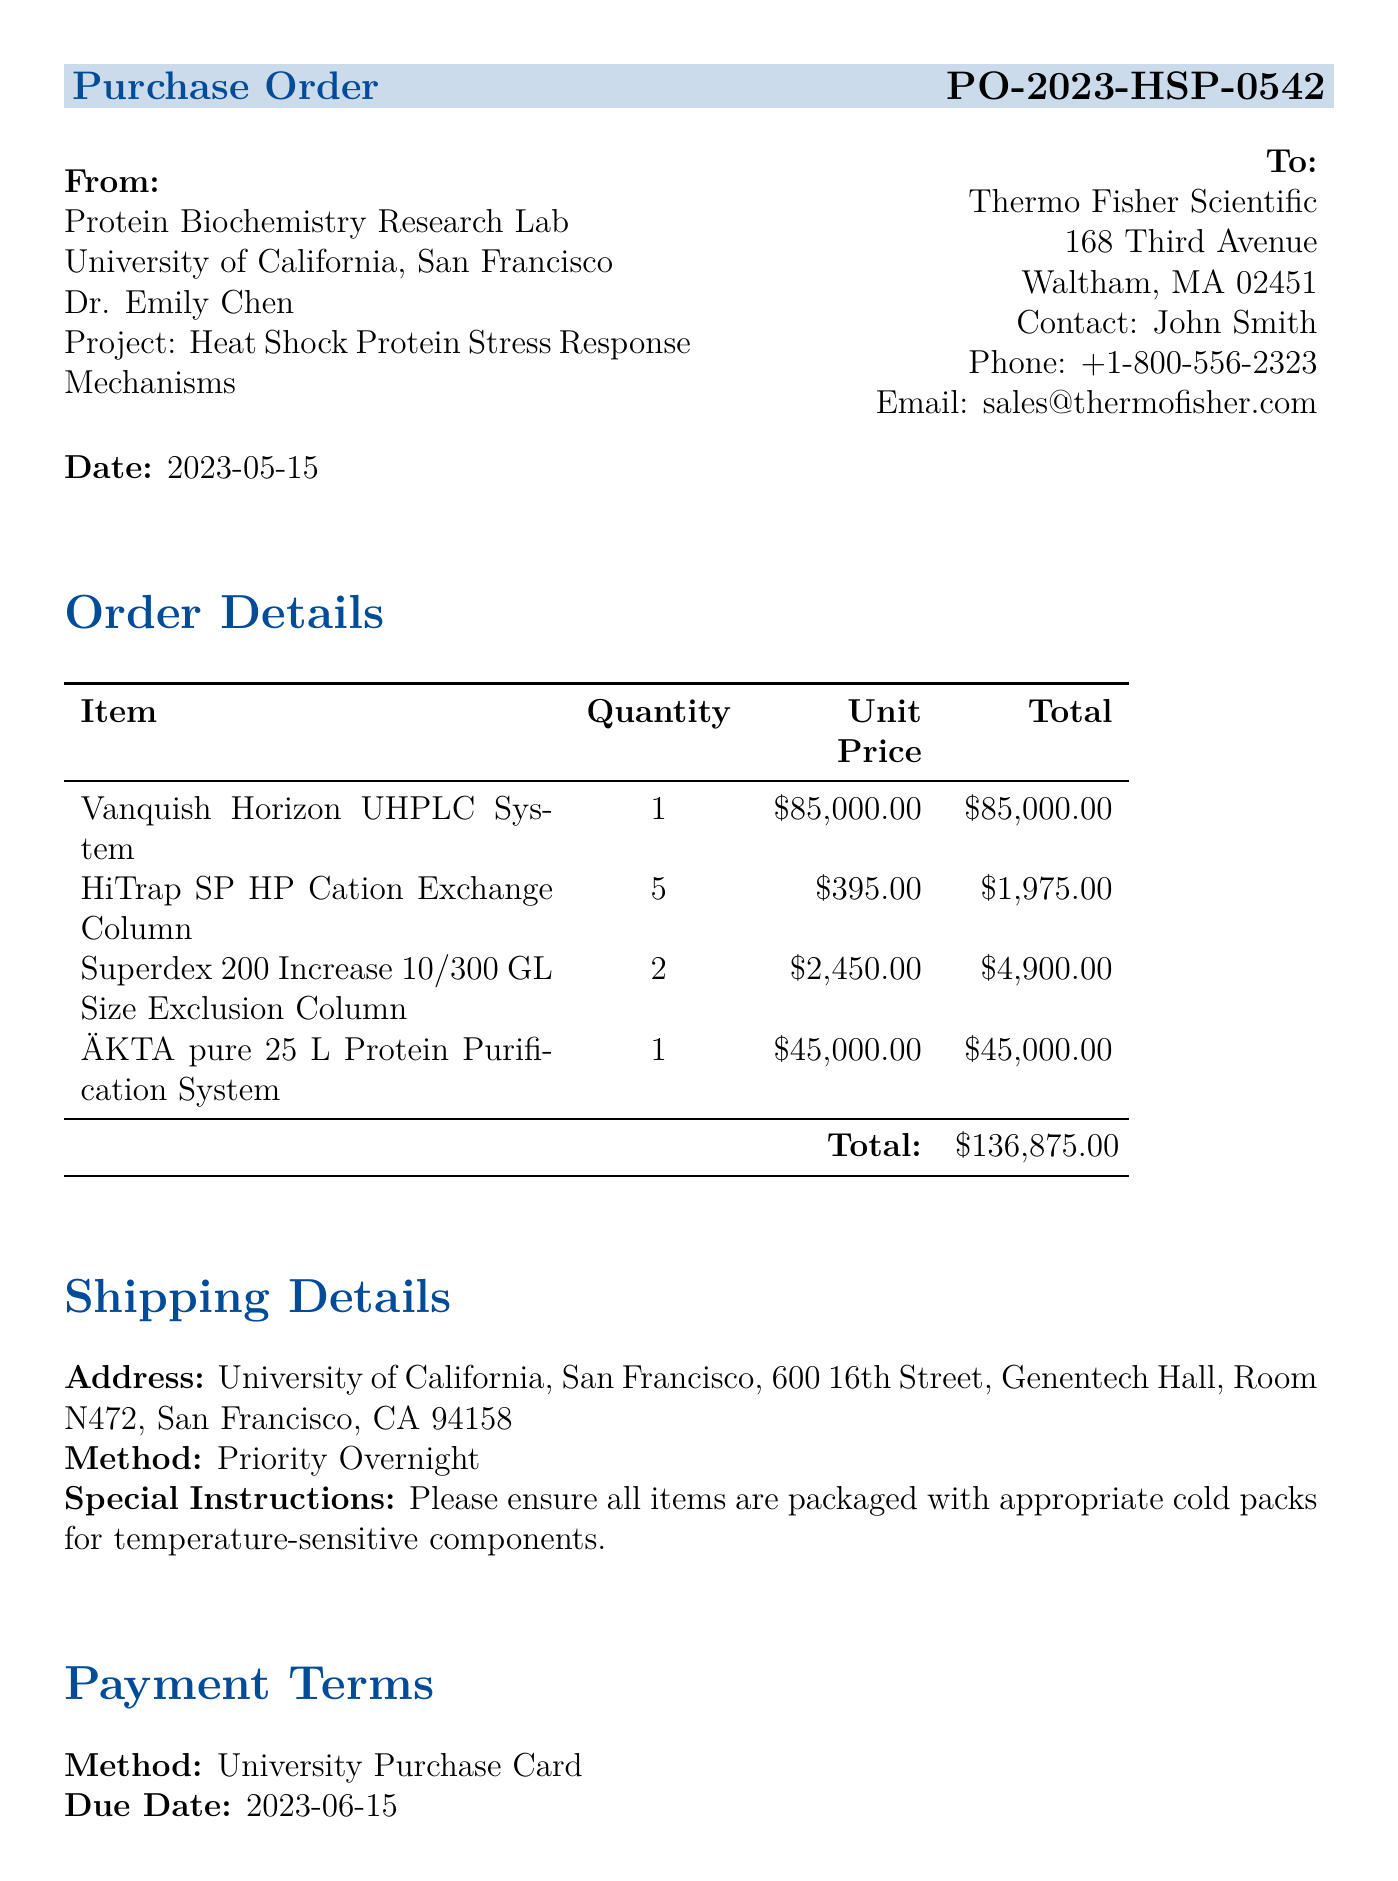What is the order number? The order number is provided in the document under purchase order details, which is PO-2023-HSP-0542.
Answer: PO-2023-HSP-0542 Who is the principal investigator? The principal investigator is mentioned in the approvals section of the document as Dr. Emily Chen.
Answer: Dr. Emily Chen What is the total price of the Vanquish Horizon UHPLC System? The total price of the Vanquish Horizon UHPLC System is listed in the order details section, which is $85,000.00.
Answer: $85,000.00 How many HiTrap SP HP Cation Exchange Columns were ordered? The quantity of HiTrap SP HP Cation Exchange Columns is specified in the order details as 5.
Answer: 5 What is the shipping method? The shipping method is indicated in the shipping details section, which states "Priority Overnight."
Answer: Priority Overnight What is the due date for the payment? The due date for the payment can be found in the payment terms section, which is 2023-06-15.
Answer: 2023-06-15 Which department is responsible for this purchase? The responsible department is stated in the purchase order details as the Protein Biochemistry Research Lab.
Answer: Protein Biochemistry Research Lab What special instruction is given for shipping? The special instruction for shipping is noted in the shipping details, specifying the need for cold packs for temperature-sensitive components.
Answer: Please ensure all items are packaged with appropriate cold packs for temperature-sensitive components What is the project title associated with this purchase order? The project title is provided in the purchase order details as "Heat Shock Protein Stress Response Mechanisms."
Answer: Heat Shock Protein Stress Response Mechanisms 